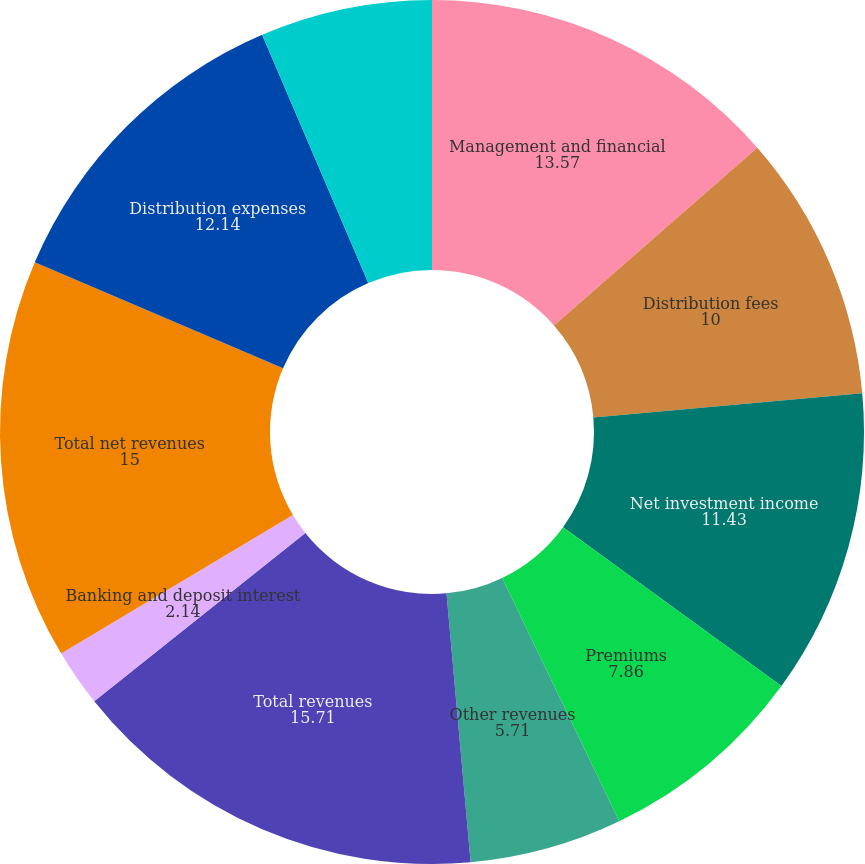Convert chart. <chart><loc_0><loc_0><loc_500><loc_500><pie_chart><fcel>Management and financial<fcel>Distribution fees<fcel>Net investment income<fcel>Premiums<fcel>Other revenues<fcel>Total revenues<fcel>Banking and deposit interest<fcel>Total net revenues<fcel>Distribution expenses<fcel>Interest credited to fixed<nl><fcel>13.57%<fcel>10.0%<fcel>11.43%<fcel>7.86%<fcel>5.71%<fcel>15.71%<fcel>2.14%<fcel>15.0%<fcel>12.14%<fcel>6.43%<nl></chart> 